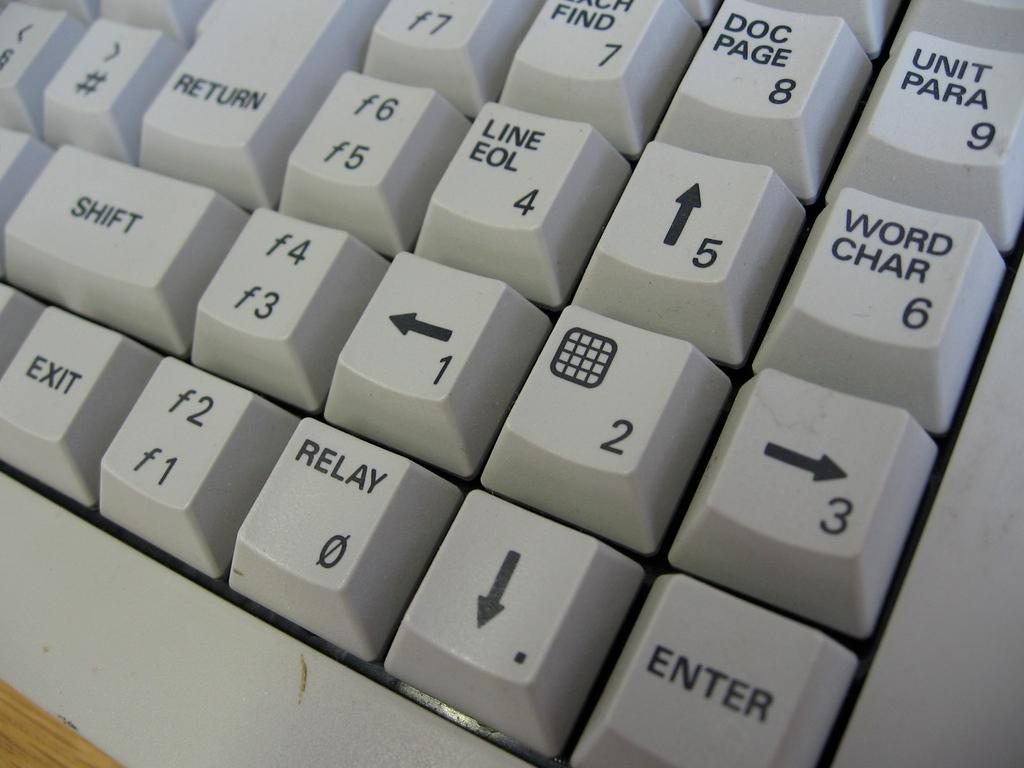<image>
Offer a succinct explanation of the picture presented. White keyboard with the key "Unit Para" on the top right. 